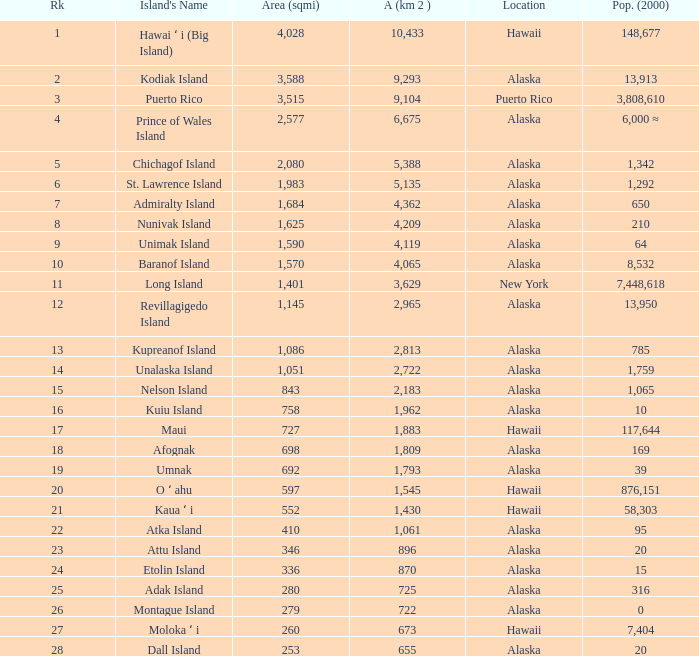What is the largest area in Alaska with a population of 39 and rank over 19? None. 